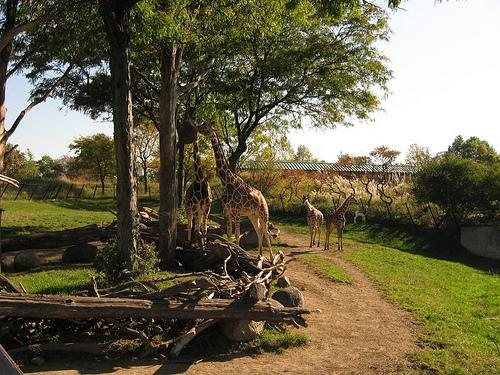Protected areas for these types of animals are known as what?

Choices:
A) states
B) wildlife reserves
C) demilitarized zones
D) unions wildlife reserves 